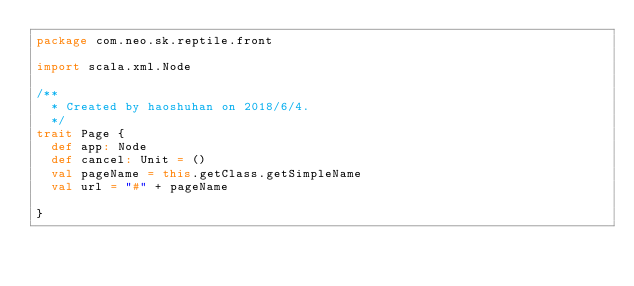Convert code to text. <code><loc_0><loc_0><loc_500><loc_500><_Scala_>package com.neo.sk.reptile.front

import scala.xml.Node

/**
  * Created by haoshuhan on 2018/6/4.
  */
trait Page {
  def app: Node
  def cancel: Unit = ()
  val pageName = this.getClass.getSimpleName
  val url = "#" + pageName

}
</code> 